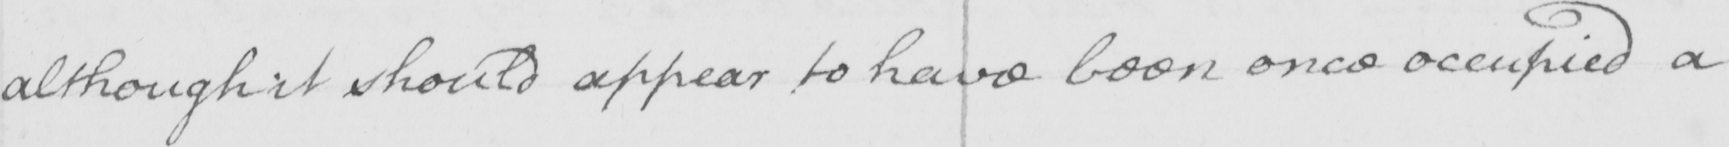What does this handwritten line say? although it should appear to have been once occupied a 